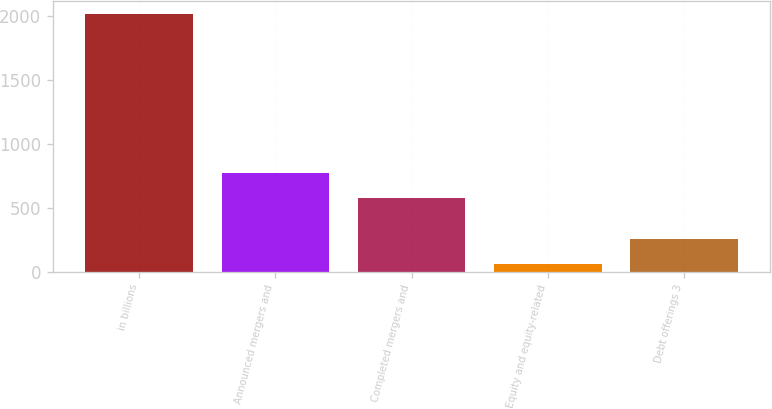<chart> <loc_0><loc_0><loc_500><loc_500><bar_chart><fcel>in billions<fcel>Announced mergers and<fcel>Completed mergers and<fcel>Equity and equity-related<fcel>Debt offerings 3<nl><fcel>2012<fcel>769.5<fcel>574<fcel>57<fcel>252.5<nl></chart> 